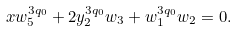<formula> <loc_0><loc_0><loc_500><loc_500>x w _ { 5 } ^ { 3 q _ { 0 } } + 2 y _ { 2 } ^ { 3 q _ { 0 } } w _ { 3 } + w _ { 1 } ^ { 3 q _ { 0 } } w _ { 2 } = 0 .</formula> 